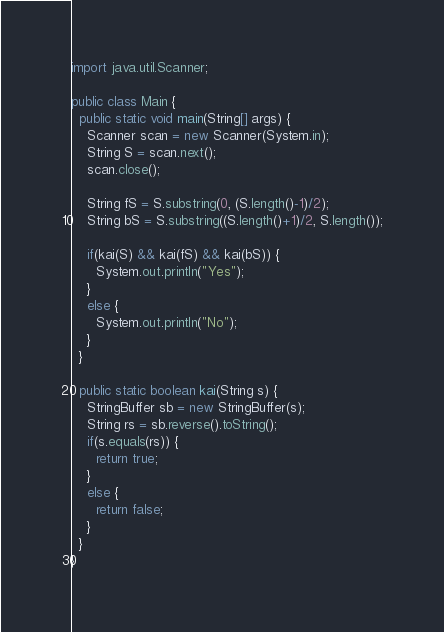Convert code to text. <code><loc_0><loc_0><loc_500><loc_500><_Java_>import java.util.Scanner;

public class Main {
  public static void main(String[] args) {
    Scanner scan = new Scanner(System.in);
    String S = scan.next();
    scan.close();

    String fS = S.substring(0, (S.length()-1)/2);
    String bS = S.substring((S.length()+1)/2, S.length());

    if(kai(S) && kai(fS) && kai(bS)) {
      System.out.println("Yes");
    }
    else {
      System.out.println("No");
    }
  }

  public static boolean kai(String s) {
    StringBuffer sb = new StringBuffer(s);
    String rs = sb.reverse().toString();
    if(s.equals(rs)) {
      return true;
    }
    else {
      return false;
    }
  }
}</code> 